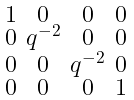Convert formula to latex. <formula><loc_0><loc_0><loc_500><loc_500>\begin{smallmatrix} 1 & 0 & 0 & 0 \\ 0 & q ^ { - 2 } & 0 & 0 \\ 0 & 0 & q ^ { - 2 } & 0 \\ 0 & 0 & 0 & 1 \end{smallmatrix}</formula> 